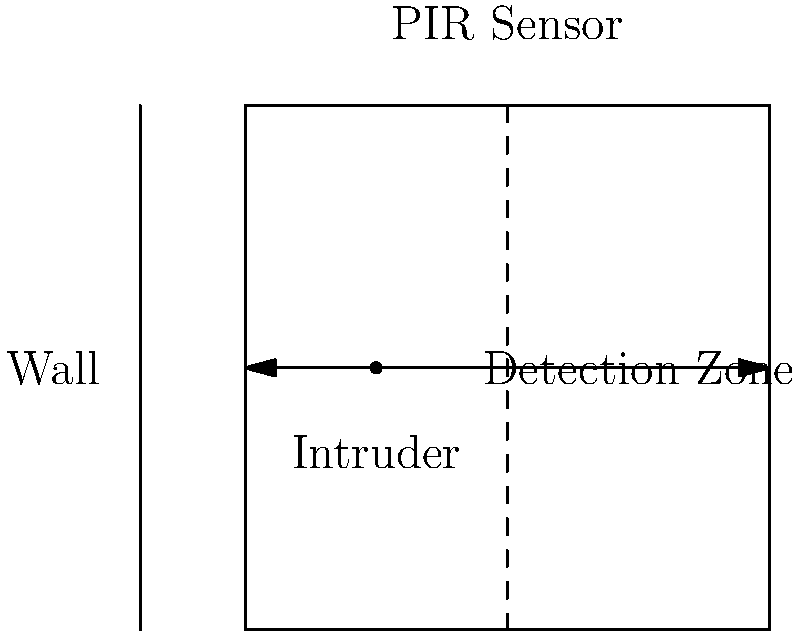In a covert operation, you need to quickly assemble a motion detection system using a Passive Infrared (PIR) sensor. The sensor has a detection range of 5 meters and a field of view of 90°. If an intruder moves at a speed of 1.5 m/s perpendicular to the sensor's line of sight, how long will they be in the detection zone? Assume the sensor is mounted flush with the wall. To solve this problem, we need to follow these steps:

1. Calculate the width of the detection zone:
   The sensor has a 90° field of view and a 5m range.
   Width = $2 * 5m * \sin(45°) = 2 * 5m * \frac{\sqrt{2}}{2} = 5\sqrt{2}$ meters

2. Calculate the time the intruder spends in the detection zone:
   Time = Distance / Speed
   Time = $\frac{5\sqrt{2}\ m}{1.5\ m/s}$

3. Simplify the expression:
   Time = $\frac{5\sqrt{2}}{1.5} = \frac{10\sqrt{2}}{3}$ seconds

4. Calculate the final value:
   Time ≈ 4.71 seconds

Therefore, the intruder will be in the detection zone for approximately 4.71 seconds.
Answer: 4.71 seconds 